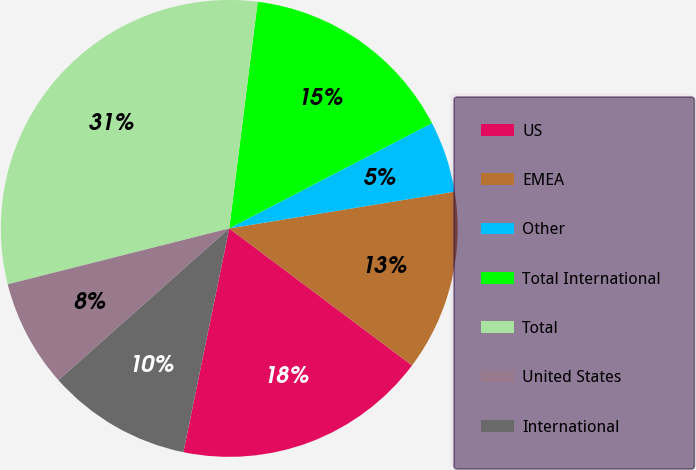Convert chart. <chart><loc_0><loc_0><loc_500><loc_500><pie_chart><fcel>US<fcel>EMEA<fcel>Other<fcel>Total International<fcel>Total<fcel>United States<fcel>International<nl><fcel>17.98%<fcel>12.81%<fcel>5.05%<fcel>15.39%<fcel>30.92%<fcel>7.63%<fcel>10.22%<nl></chart> 